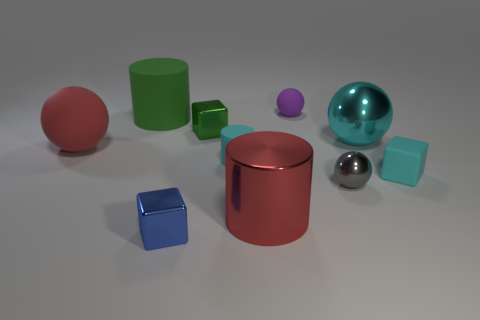Is the number of small blue metal objects that are right of the tiny purple sphere less than the number of large cyan spheres left of the red cylinder?
Offer a very short reply. No. Is there a big matte thing of the same color as the large shiny cylinder?
Your response must be concise. Yes. Is the material of the cyan block the same as the small ball in front of the large green rubber cylinder?
Offer a very short reply. No. Is there a large red object that is behind the big metallic object that is in front of the cyan cylinder?
Your response must be concise. Yes. The tiny object that is in front of the tiny cyan rubber cylinder and to the left of the purple matte ball is what color?
Offer a very short reply. Blue. The gray sphere is what size?
Keep it short and to the point. Small. How many gray shiny balls are the same size as the blue shiny block?
Make the answer very short. 1. Are the tiny cyan thing that is behind the small cyan matte cube and the tiny block right of the small purple rubber ball made of the same material?
Your response must be concise. Yes. There is a big ball that is left of the metallic block behind the small blue object; what is its material?
Keep it short and to the point. Rubber. What material is the cyan object that is behind the red rubber ball?
Your answer should be very brief. Metal. 